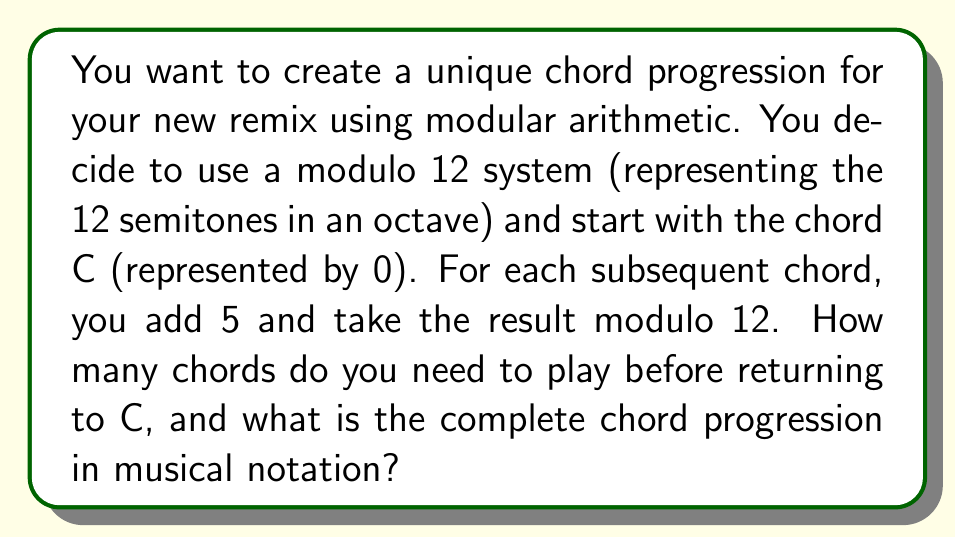Show me your answer to this math problem. Let's approach this step-by-step:

1) We start with C, represented by 0 in mod 12.

2) For each step, we add 5 and take the result modulo 12:
   
   Step 1: $(0 + 5) \equiv 5 \pmod{12}$ (F)
   Step 2: $(5 + 5) \equiv 10 \pmod{12}$ (A#/Bb)
   Step 3: $(10 + 5) \equiv 3 \pmod{12}$ (D#/Eb)
   Step 4: $(3 + 5) \equiv 8 \pmod{12}$ (G#/Ab)
   Step 5: $(8 + 5) \equiv 1 \pmod{12}$ (C#/Db)
   Step 6: $(1 + 5) \equiv 6 \pmod{12}$ (F#/Gb)
   Step 7: $(6 + 5) \equiv 11 \pmod{12}$ (B)
   Step 8: $(11 + 5) \equiv 4 \pmod{12}$ (E)
   Step 9: $(4 + 5) \equiv 9 \pmod{12}$ (A)
   Step 10: $(9 + 5) \equiv 2 \pmod{12}$ (D)
   Step 11: $(2 + 5) \equiv 7 \pmod{12}$ (G)
   Step 12: $(7 + 5) \equiv 0 \pmod{12}$ (C)

3) We return to C after 12 steps.

4) The complete chord progression in musical notation is:
   C - F - A#/Bb - D#/Eb - G#/Ab - C#/Db - F#/Gb - B - E - A - D - G - C
Answer: 12 chords; C-F-A#-D#-G#-C#-F#-B-E-A-D-G-C 